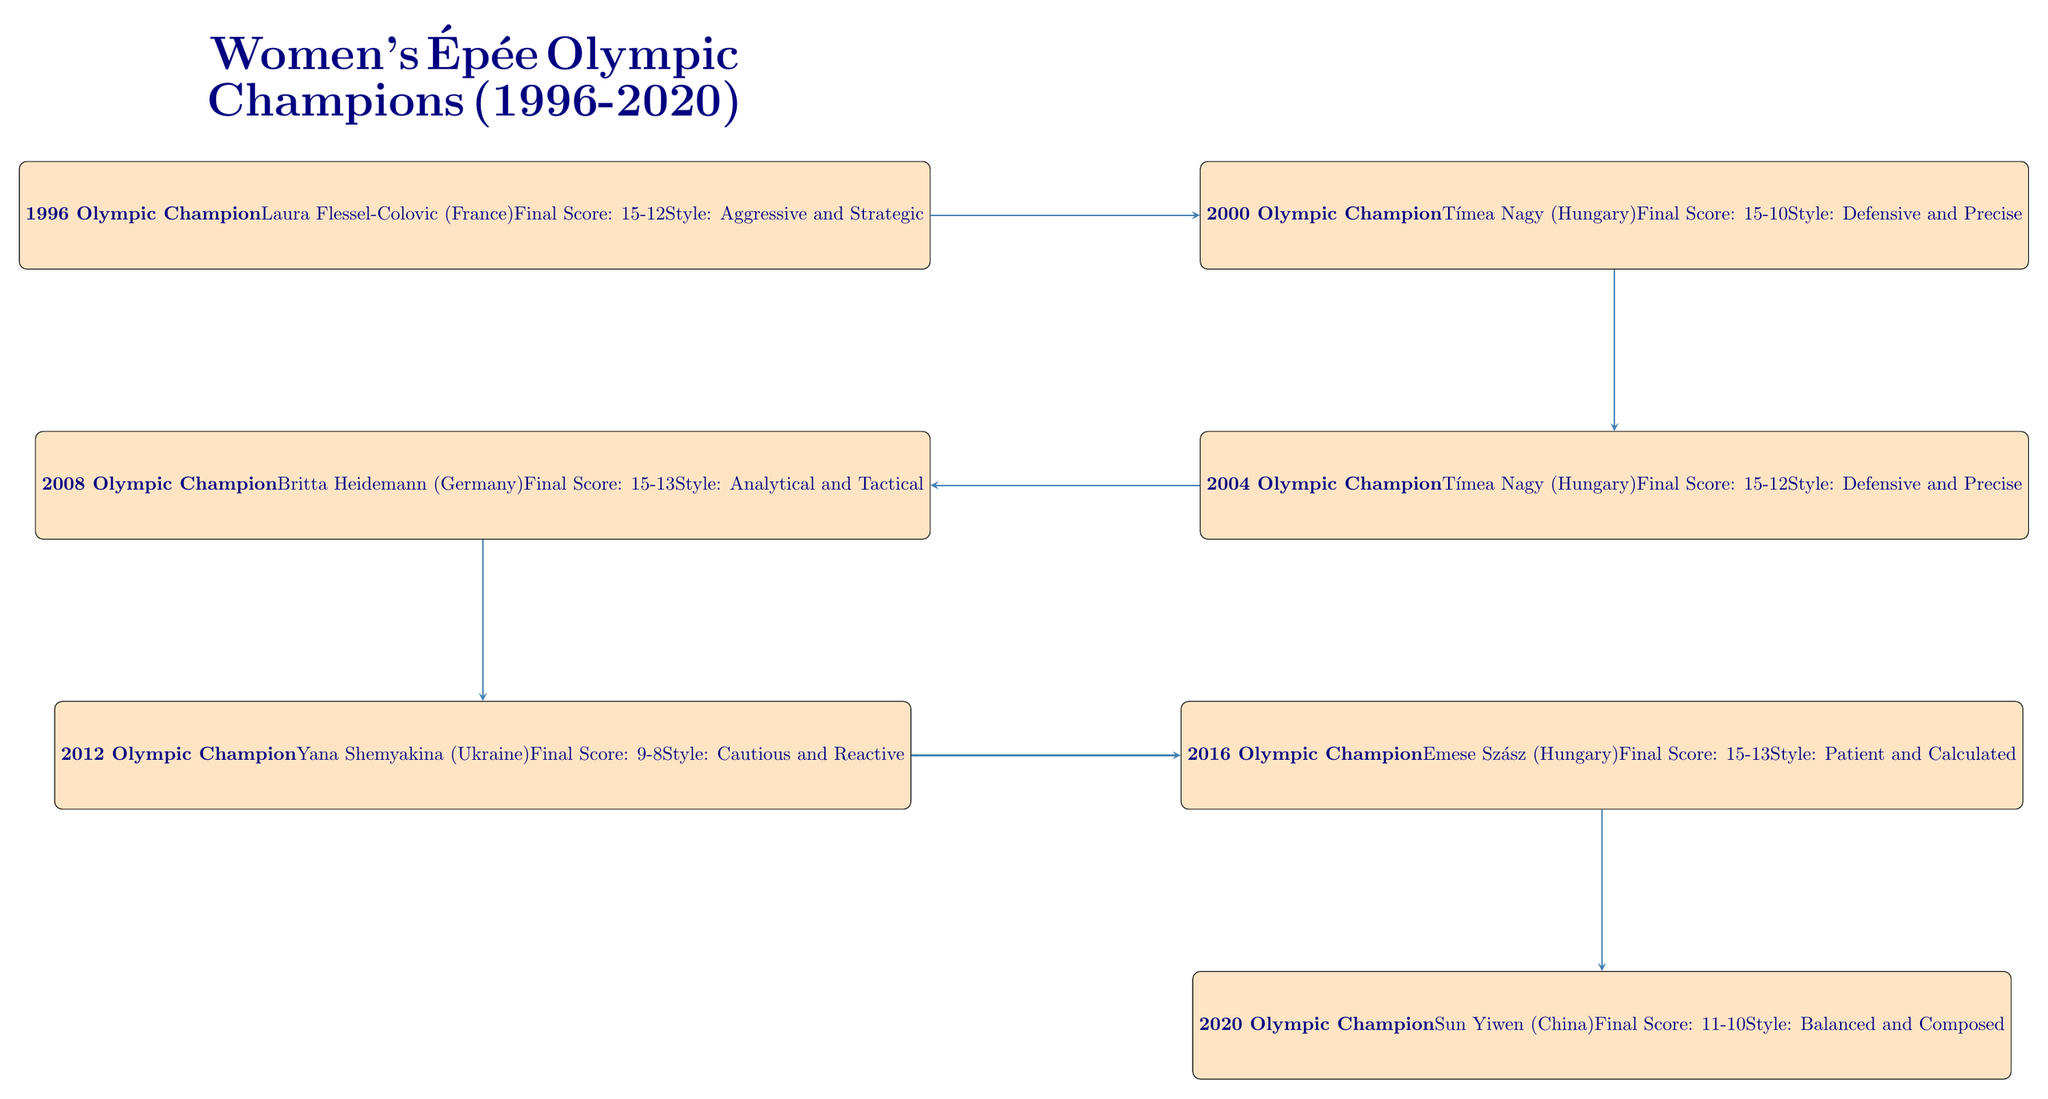What year did Laura Flessel-Colovic win the Olympic Championship? Laura Flessel-Colovic's name is listed in the node for the year 1996, which indicates that she won the Olympic Championship in that year.
Answer: 1996 Who won the Olympic Championship in 2008? The node for 2008 clearly states that Britta Heidemann (Germany) was the champion for that year.
Answer: Britta Heidemann What was the final score in the 2016 Olympics? The node for 2016 shows "Final Score: 15-13", directly providing the score from that year's final bout.
Answer: 15-13 Which country did the 2020 champion represent? Sun Yiwen, the 2020 champion, is identified in the diagram as representing China, which is specified in her node.
Answer: China How many times did Tímea Nagy win the Olympic Championship according to this diagram? Tímea Nagy is mentioned in both the 2000 and 2004 nodes as the champion, meaning she won two times.
Answer: 2 What is the fencing style of the 2012 champion? Yana Shemyakina's node in the 2012 section mentions her style as "Cautious and Reactive," providing us with her identified style.
Answer: Cautious and Reactive Which Olympic champions had a defensive fencing style? By examining the nodes for Tímea Nagy in 2000 and 2004, we see her style is described as "Defensive and Precise," indicating both years featured a champion with this style.
Answer: Tímea Nagy What was the final bout score of the 2020 Olympic champion? The node for 2020 shows "Final Score: 11-10," which directly identifies the final score of Sun Yiwen's championship match.
Answer: 11-10 